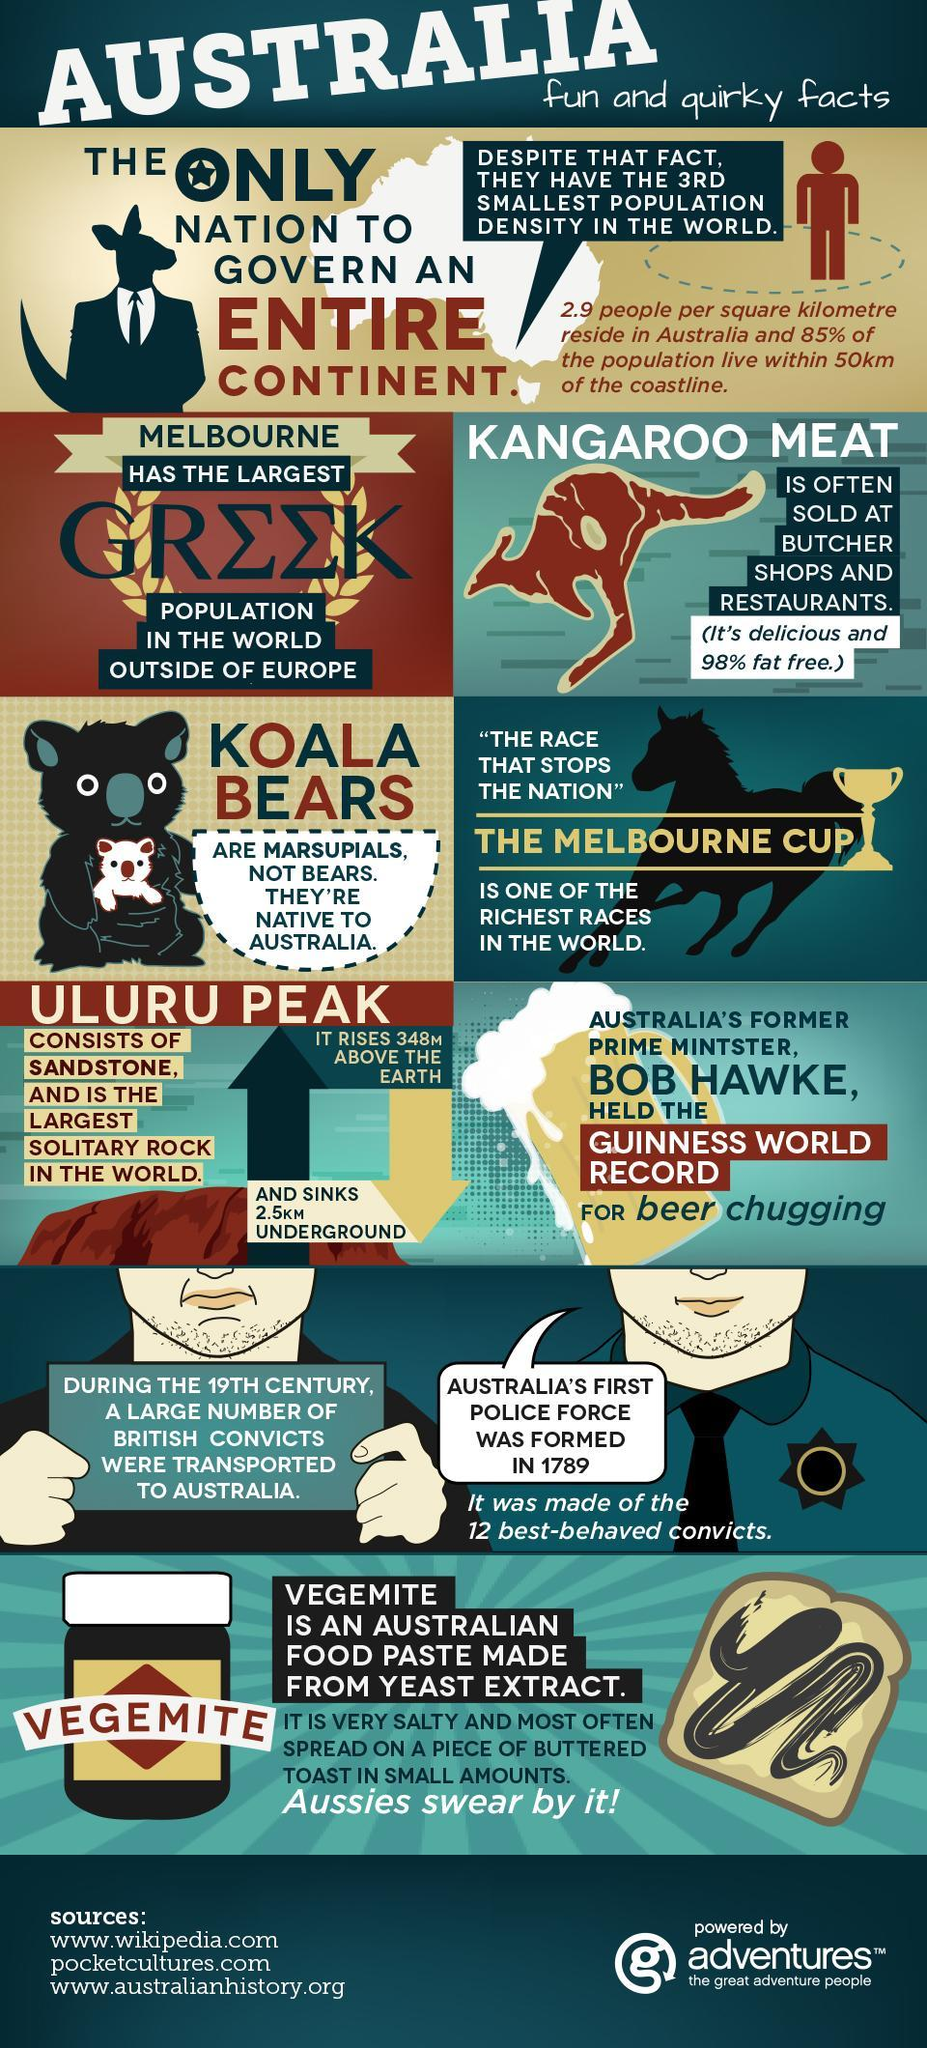Which animal's picture is shown as the background of 'the Melbourne cup' block- Horse or Cow?
Answer the question with a short phrase. Horse Which race is the richest of its kind in the world? The Melbourne cup What was made of the 12 best-behaved convicts in 1789? Australia's first police force 